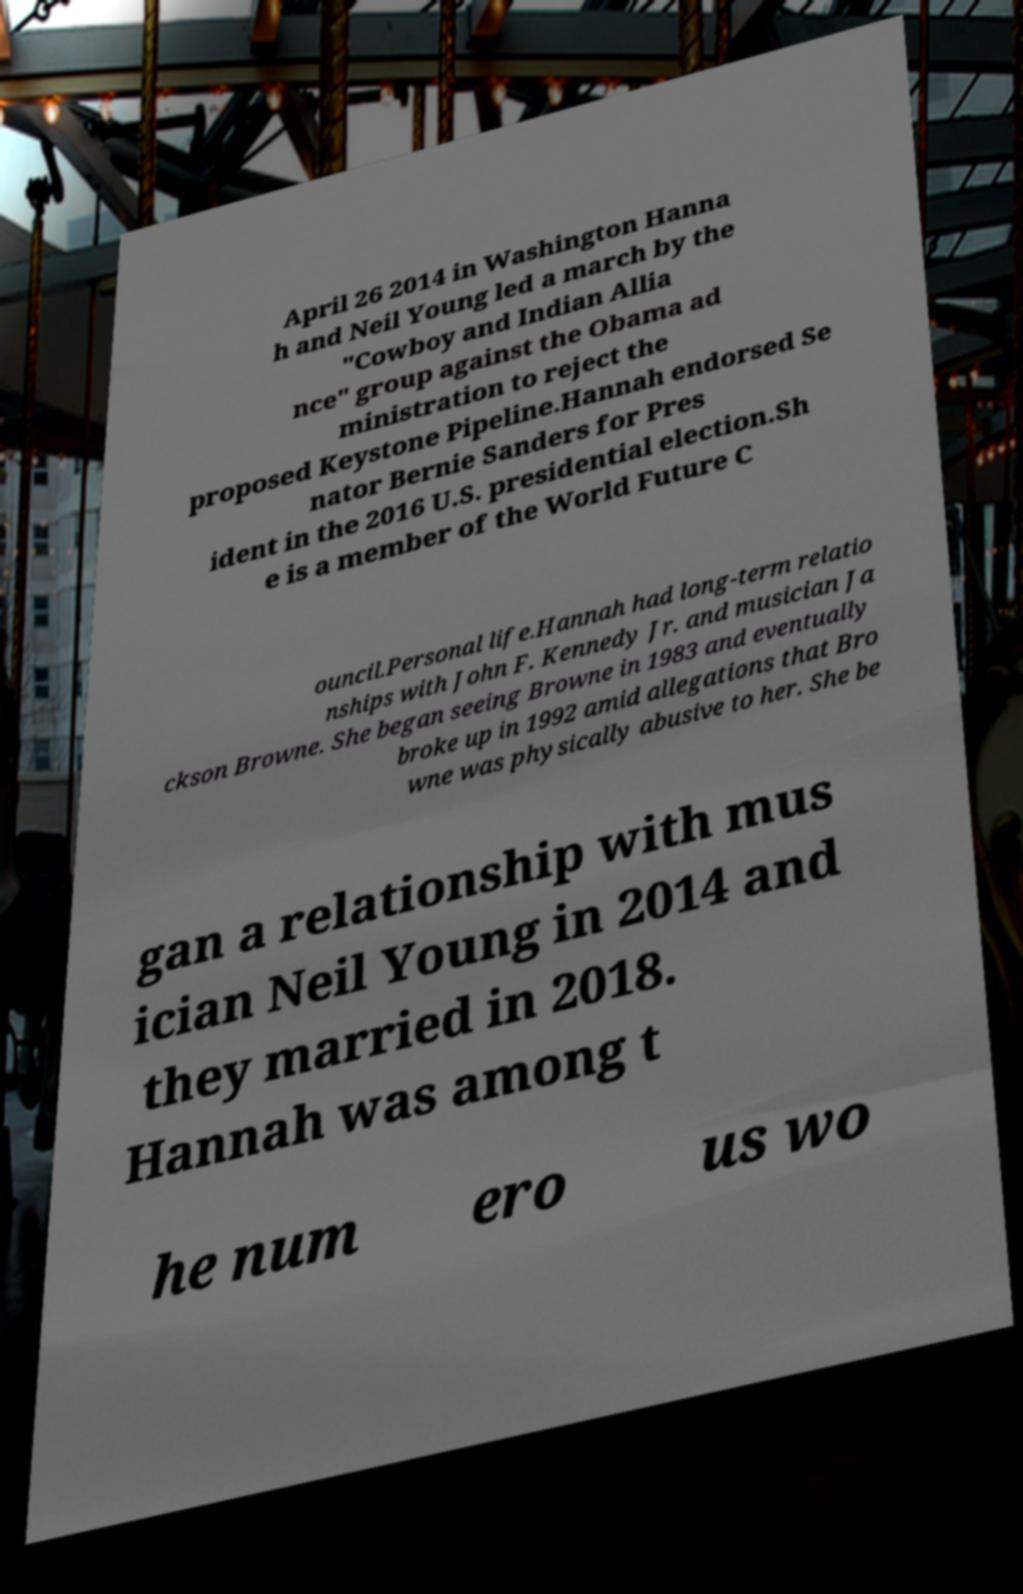There's text embedded in this image that I need extracted. Can you transcribe it verbatim? April 26 2014 in Washington Hanna h and Neil Young led a march by the "Cowboy and Indian Allia nce" group against the Obama ad ministration to reject the proposed Keystone Pipeline.Hannah endorsed Se nator Bernie Sanders for Pres ident in the 2016 U.S. presidential election.Sh e is a member of the World Future C ouncil.Personal life.Hannah had long-term relatio nships with John F. Kennedy Jr. and musician Ja ckson Browne. She began seeing Browne in 1983 and eventually broke up in 1992 amid allegations that Bro wne was physically abusive to her. She be gan a relationship with mus ician Neil Young in 2014 and they married in 2018. Hannah was among t he num ero us wo 